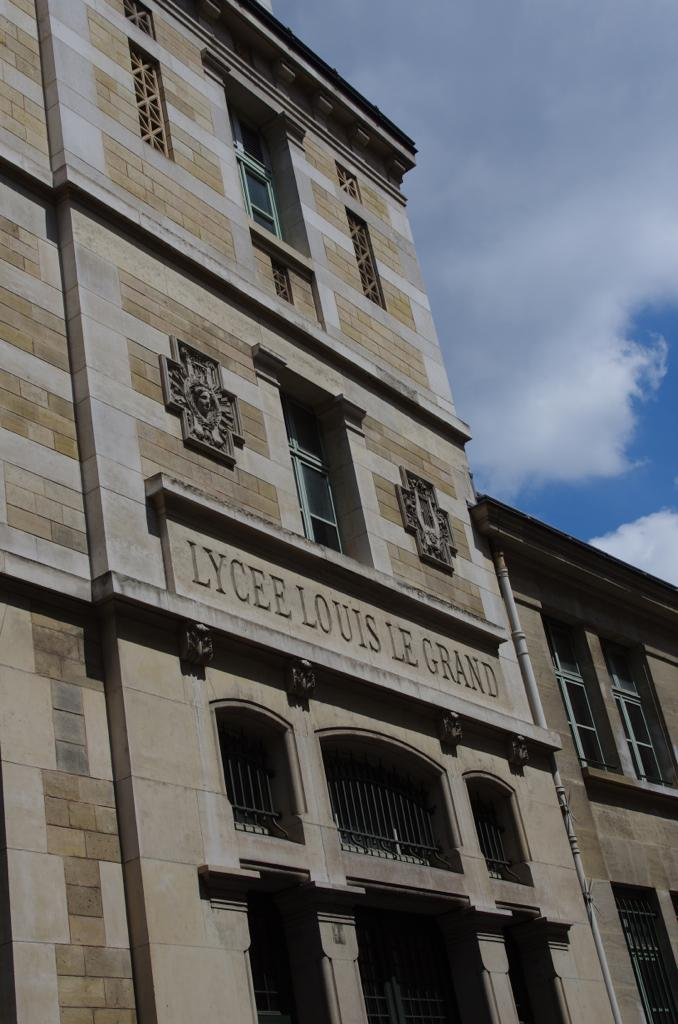What type of structure is present in the image? There is a building in the image. What can be seen in the background of the image? The sky is visible in the background of the image. How many cacti are present in the image? There are no cacti present in the image; it only features a building and the sky. Who is the partner of the person in the image? There is no person present in the image, so it is impossible to determine who their partner might be. 